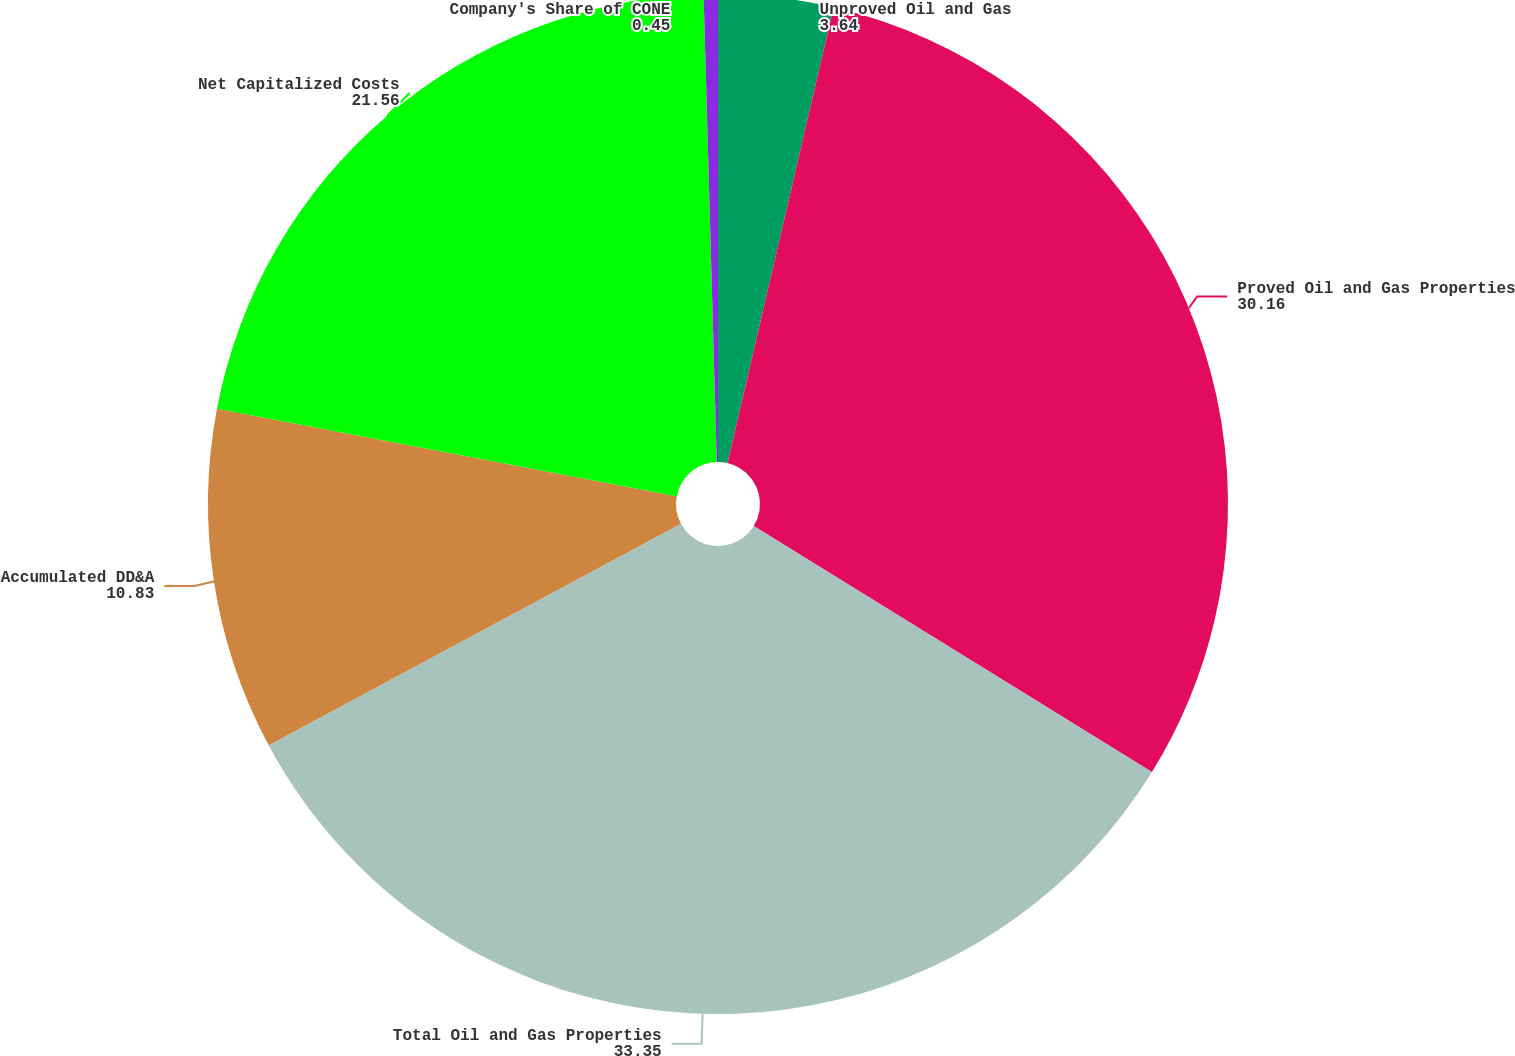Convert chart to OTSL. <chart><loc_0><loc_0><loc_500><loc_500><pie_chart><fcel>Unproved Oil and Gas<fcel>Proved Oil and Gas Properties<fcel>Total Oil and Gas Properties<fcel>Accumulated DD&A<fcel>Net Capitalized Costs<fcel>Company's Share of CONE<nl><fcel>3.64%<fcel>30.16%<fcel>33.35%<fcel>10.83%<fcel>21.56%<fcel>0.45%<nl></chart> 